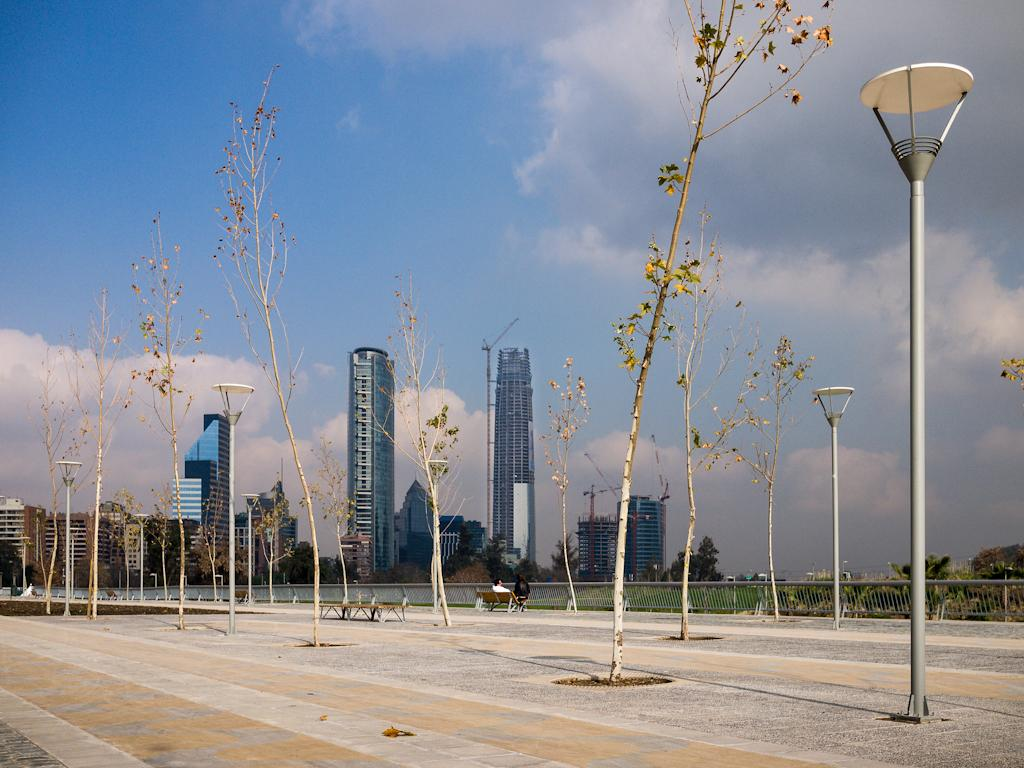What type of structures can be seen in the image? There are many big buildings in the image. How would you describe the sky in the image? The sky is cloudy in the image. Are there any natural elements present in the image? Yes, there are plants in the image. What type of seating can be seen in the image? There are benches in the image. Are there any people using the benches? Yes, there are persons sitting on the benches. What other man-made structures can be seen in the image? There is a light pole and a street in the image. How many cellars are visible in the image? There are no cellars visible in the image. What time of day is depicted in the image? The provided facts do not give information about the time of day, so it cannot be determined from the image. 